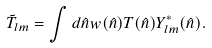Convert formula to latex. <formula><loc_0><loc_0><loc_500><loc_500>\tilde { T } _ { l m } = \int d \hat { n } w ( \hat { n } ) T ( \hat { n } ) Y ^ { * } _ { l m } ( \hat { n } ) .</formula> 